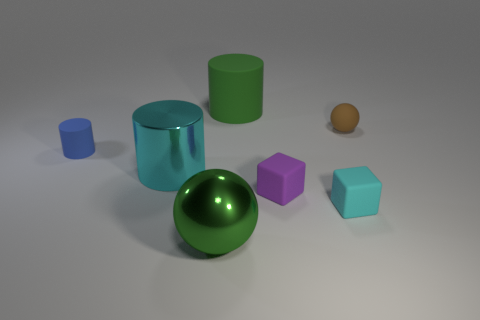There is a matte cylinder that is left of the metallic object in front of the cyan cylinder; what color is it?
Provide a short and direct response. Blue. Are there any cyan shiny things of the same size as the green metal thing?
Provide a short and direct response. Yes. What is the large green thing that is behind the large cylinder in front of the large cylinder to the right of the large cyan metal cylinder made of?
Provide a succinct answer. Rubber. How many balls are on the right side of the green object that is behind the big green ball?
Offer a very short reply. 1. Does the green object that is in front of the cyan matte cube have the same size as the large green cylinder?
Your answer should be very brief. Yes. How many other metal objects have the same shape as the purple thing?
Your answer should be compact. 0. What is the shape of the brown matte thing?
Ensure brevity in your answer.  Sphere. Is the number of small purple blocks behind the green rubber thing the same as the number of big purple cylinders?
Your answer should be very brief. Yes. Does the tiny object that is to the left of the green matte cylinder have the same material as the green cylinder?
Your answer should be compact. Yes. Is the number of tiny purple matte blocks that are behind the cyan metal thing less than the number of small cubes?
Give a very brief answer. Yes. 